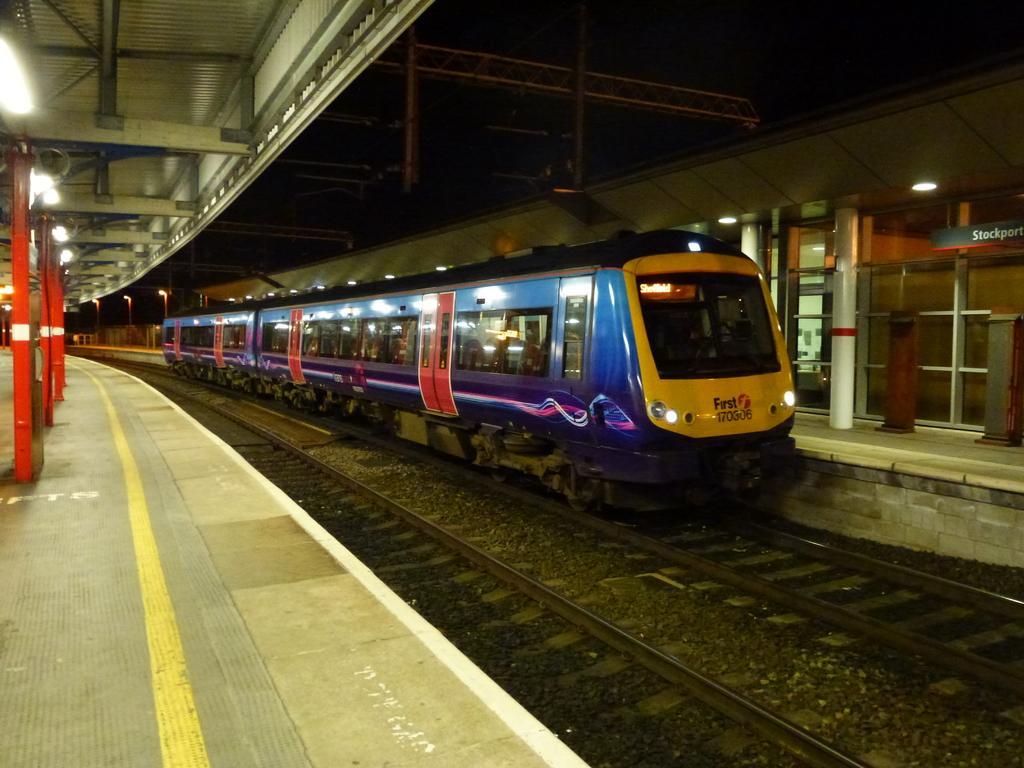Could you give a brief overview of what you see in this image? In the picture there is a train on the track and the platforms around the train are empty. 